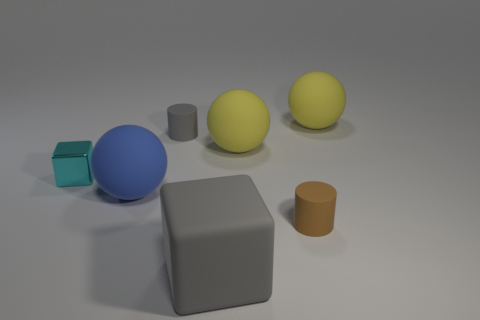What is the lighting like in the scene, and does it seem to have a source within the image frame? The lighting in the image is soft and diffuse, suggesting that the light source is not visible within the frame. It appears to be coming from above, as indicated by the shadows under the objects which suggest an overhead illumination.  How do the shadows help us understand the shape of the objects? The shadows can give us clues about the shape and the three-dimensionality of the objects. For instance, the elongated shadow of the cylinder reveals its circular base, and the distinct edges in the shadow of the cube accentuate its geometric form. 